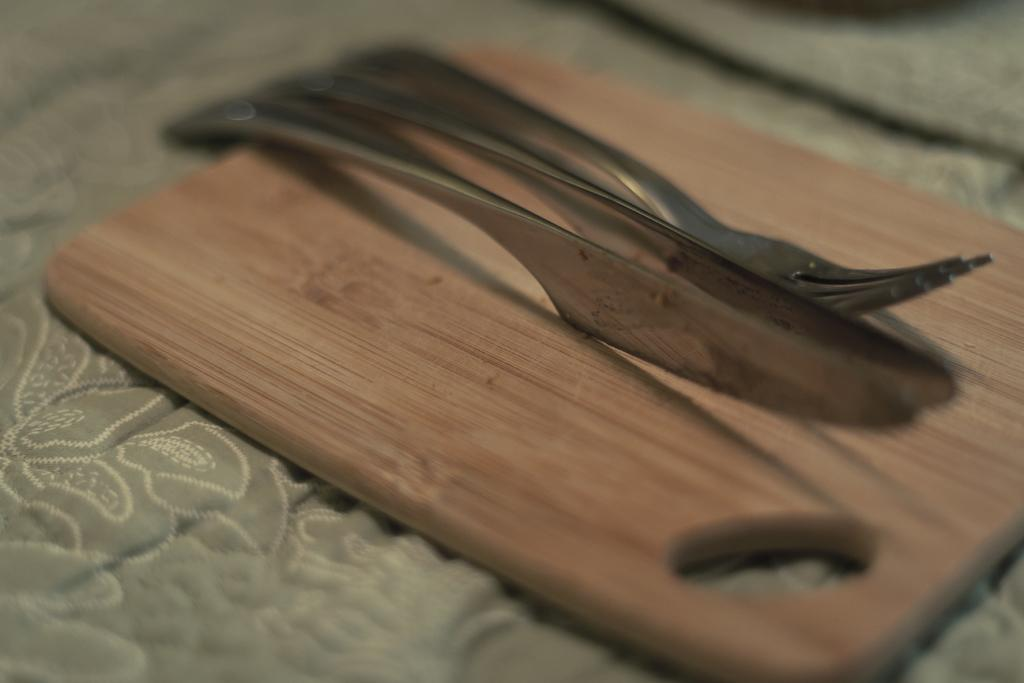What is the main object in the center of the image? There is a cutting board in the center of the image. What is placed on the cutting board? There are spoons on the cutting board. What can be seen in the background of the image? There is a blanket in the background of the image. What is the condition of the plough in the image? There is no plough present in the image. What does the mom say about the blanket in the image? There is no mom present in the image, and therefore no statement can be attributed to her. 